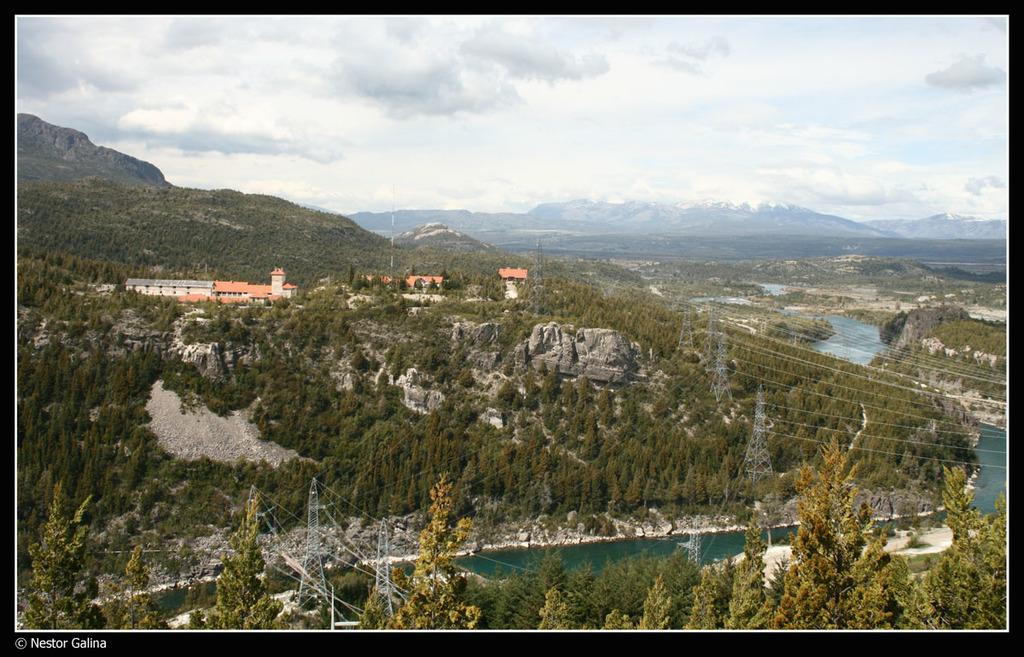What type of view is depicted in the image? The image is an aerial view. What can be seen on the left side of the image? There is a canal on the left side of the image. What is located on the right side of the image? There are buildings on the right side of the image. What is visible in the background of the image? There are hills visible in the background of the image. What is visible in the sky in the image? The sky is visible in the image, and clouds are present. Where is the duck hiding in the image? There is no duck present in the image. What type of mine is visible in the image? There is no mine present in the image. 